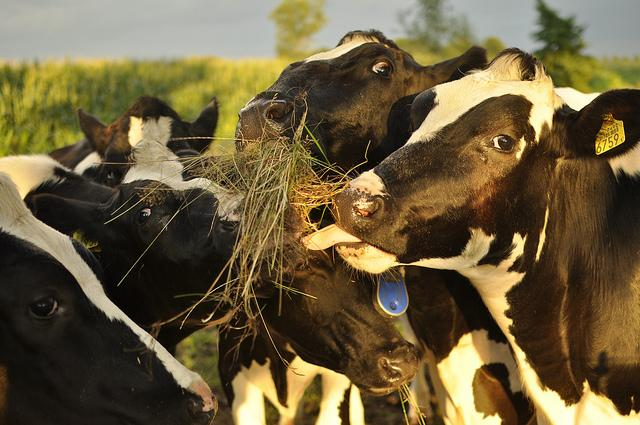What are the animals eating? hay 